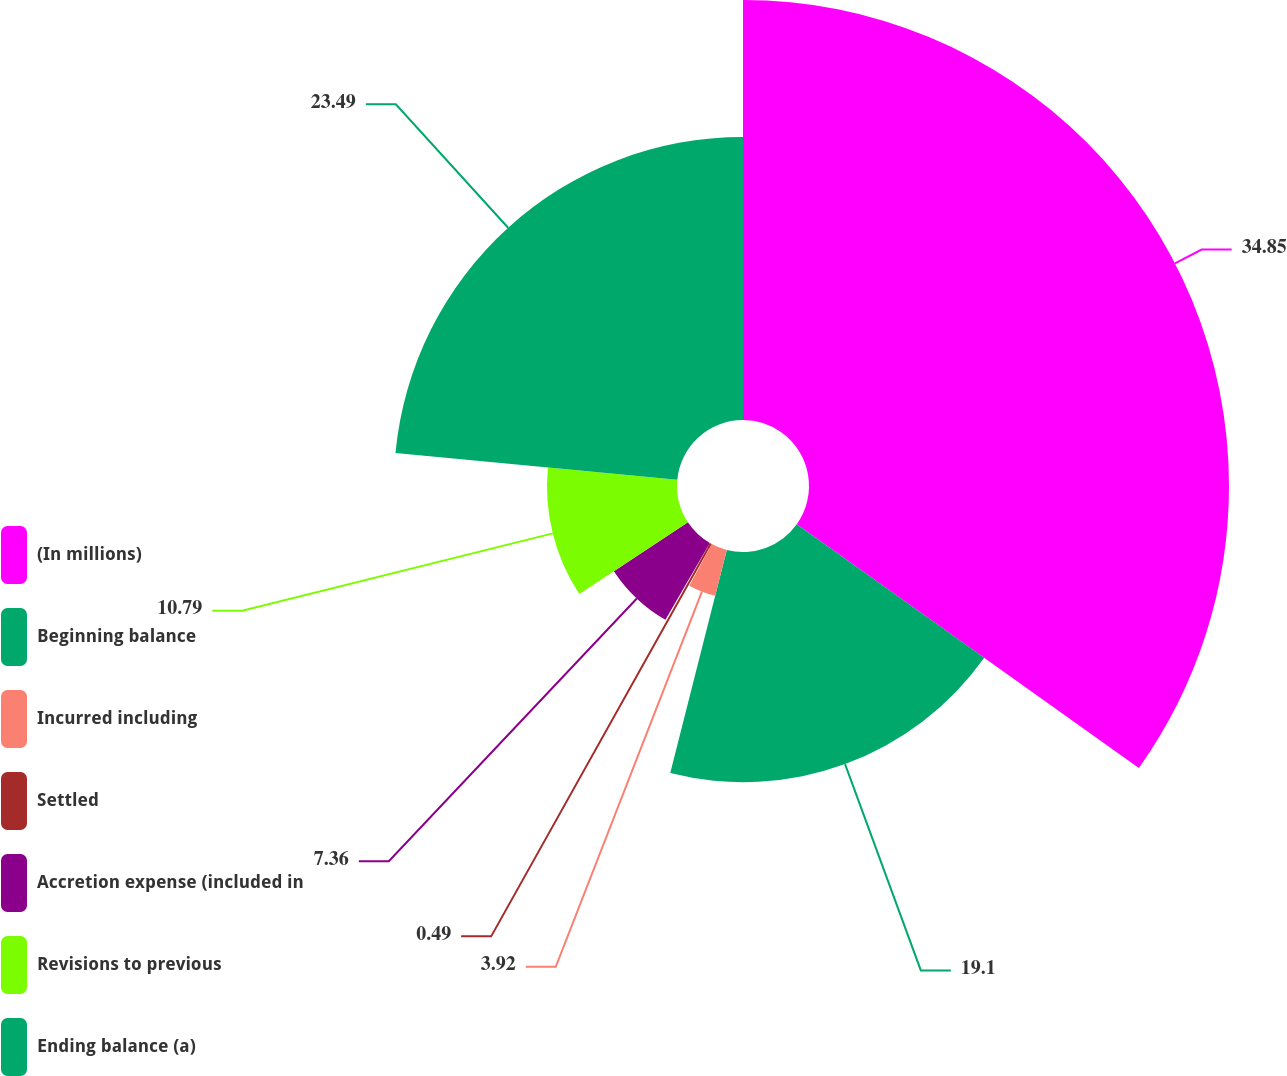<chart> <loc_0><loc_0><loc_500><loc_500><pie_chart><fcel>(In millions)<fcel>Beginning balance<fcel>Incurred including<fcel>Settled<fcel>Accretion expense (included in<fcel>Revisions to previous<fcel>Ending balance (a)<nl><fcel>34.85%<fcel>19.1%<fcel>3.92%<fcel>0.49%<fcel>7.36%<fcel>10.79%<fcel>23.49%<nl></chart> 